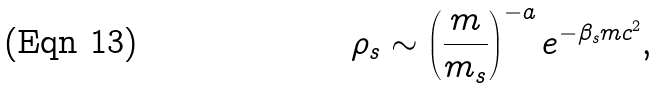Convert formula to latex. <formula><loc_0><loc_0><loc_500><loc_500>\rho _ { s } \sim \left ( \frac { m } { m _ { s } } \right ) ^ { - a } e ^ { - \beta _ { s } m c ^ { 2 } } ,</formula> 